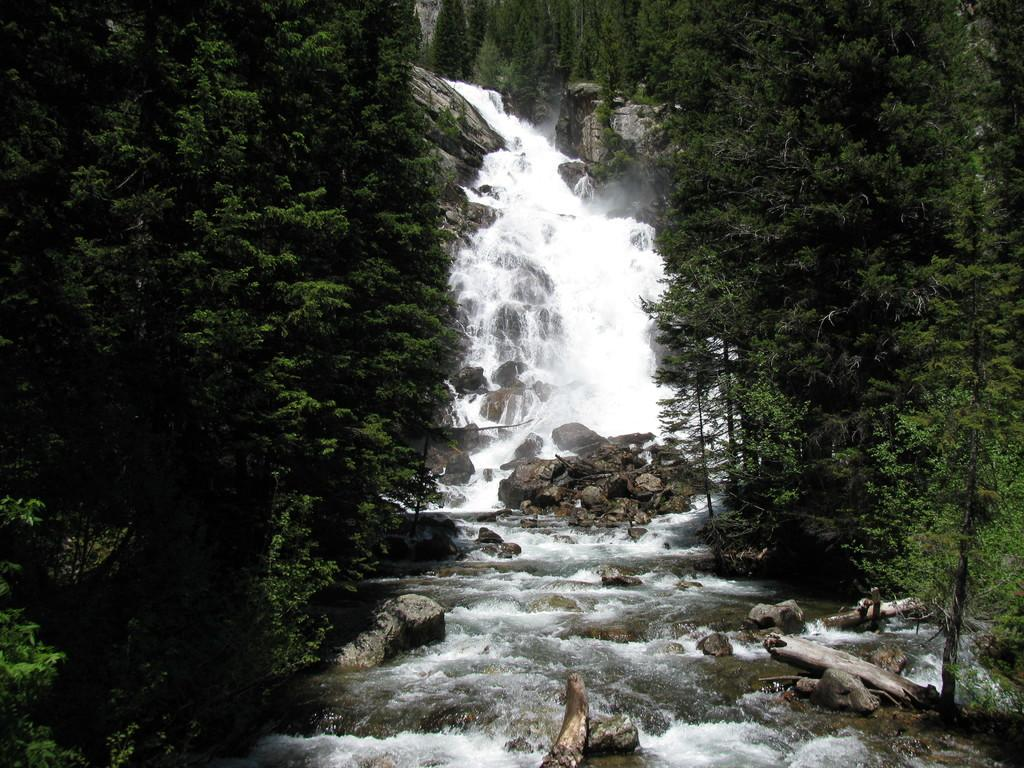What is the setting of the image? The image is an outside view. What is the main feature in the middle of the image? There is a waterfall in the middle of the image. What type of natural elements can be seen in the image? There are rocks and trees visible in the image. How are the trees distributed in the image? There are many trees on both the right and left sides of the image. What type of doctor can be seen working in the background of the image? There is no doctor present in the image; it is a natural scene featuring a waterfall and trees. What type of writer is depicted sitting on the rocks in the image? There is no writer present in the image; it is a natural scene featuring a waterfall and trees. 